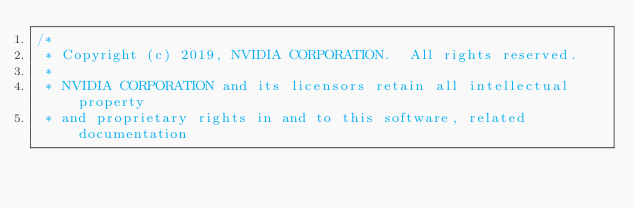Convert code to text. <code><loc_0><loc_0><loc_500><loc_500><_Cuda_>/*
 * Copyright (c) 2019, NVIDIA CORPORATION.  All rights reserved.
 *
 * NVIDIA CORPORATION and its licensors retain all intellectual property
 * and proprietary rights in and to this software, related documentation</code> 